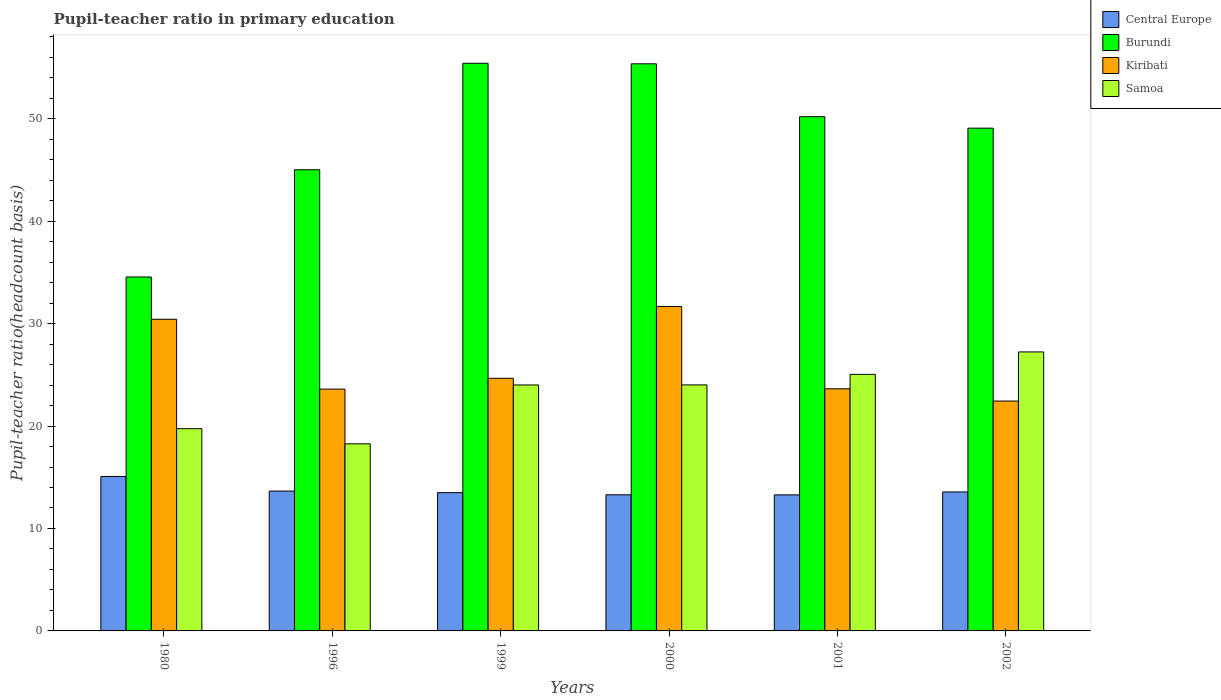How many groups of bars are there?
Provide a short and direct response. 6. How many bars are there on the 5th tick from the left?
Provide a short and direct response. 4. How many bars are there on the 1st tick from the right?
Your answer should be compact. 4. What is the pupil-teacher ratio in primary education in Samoa in 1980?
Keep it short and to the point. 19.74. Across all years, what is the maximum pupil-teacher ratio in primary education in Samoa?
Provide a short and direct response. 27.23. Across all years, what is the minimum pupil-teacher ratio in primary education in Samoa?
Provide a short and direct response. 18.26. In which year was the pupil-teacher ratio in primary education in Kiribati maximum?
Provide a short and direct response. 2000. In which year was the pupil-teacher ratio in primary education in Central Europe minimum?
Ensure brevity in your answer.  2001. What is the total pupil-teacher ratio in primary education in Samoa in the graph?
Make the answer very short. 138.31. What is the difference between the pupil-teacher ratio in primary education in Kiribati in 1996 and that in 2001?
Keep it short and to the point. -0.03. What is the difference between the pupil-teacher ratio in primary education in Central Europe in 1999 and the pupil-teacher ratio in primary education in Samoa in 1996?
Offer a very short reply. -4.77. What is the average pupil-teacher ratio in primary education in Burundi per year?
Your response must be concise. 48.27. In the year 2002, what is the difference between the pupil-teacher ratio in primary education in Burundi and pupil-teacher ratio in primary education in Samoa?
Your answer should be compact. 21.84. In how many years, is the pupil-teacher ratio in primary education in Central Europe greater than 40?
Your answer should be compact. 0. What is the ratio of the pupil-teacher ratio in primary education in Kiribati in 1999 to that in 2001?
Your response must be concise. 1.04. Is the difference between the pupil-teacher ratio in primary education in Burundi in 1999 and 2002 greater than the difference between the pupil-teacher ratio in primary education in Samoa in 1999 and 2002?
Provide a succinct answer. Yes. What is the difference between the highest and the second highest pupil-teacher ratio in primary education in Samoa?
Your response must be concise. 2.19. What is the difference between the highest and the lowest pupil-teacher ratio in primary education in Central Europe?
Keep it short and to the point. 1.79. In how many years, is the pupil-teacher ratio in primary education in Kiribati greater than the average pupil-teacher ratio in primary education in Kiribati taken over all years?
Provide a short and direct response. 2. Is it the case that in every year, the sum of the pupil-teacher ratio in primary education in Samoa and pupil-teacher ratio in primary education in Burundi is greater than the sum of pupil-teacher ratio in primary education in Kiribati and pupil-teacher ratio in primary education in Central Europe?
Your answer should be compact. Yes. What does the 1st bar from the left in 2000 represents?
Provide a short and direct response. Central Europe. What does the 1st bar from the right in 2002 represents?
Make the answer very short. Samoa. Is it the case that in every year, the sum of the pupil-teacher ratio in primary education in Burundi and pupil-teacher ratio in primary education in Samoa is greater than the pupil-teacher ratio in primary education in Kiribati?
Offer a very short reply. Yes. Are all the bars in the graph horizontal?
Offer a very short reply. No. Where does the legend appear in the graph?
Offer a terse response. Top right. What is the title of the graph?
Offer a terse response. Pupil-teacher ratio in primary education. What is the label or title of the Y-axis?
Provide a short and direct response. Pupil-teacher ratio(headcount basis). What is the Pupil-teacher ratio(headcount basis) in Central Europe in 1980?
Make the answer very short. 15.07. What is the Pupil-teacher ratio(headcount basis) in Burundi in 1980?
Ensure brevity in your answer.  34.55. What is the Pupil-teacher ratio(headcount basis) of Kiribati in 1980?
Ensure brevity in your answer.  30.43. What is the Pupil-teacher ratio(headcount basis) in Samoa in 1980?
Ensure brevity in your answer.  19.74. What is the Pupil-teacher ratio(headcount basis) in Central Europe in 1996?
Your response must be concise. 13.65. What is the Pupil-teacher ratio(headcount basis) in Burundi in 1996?
Ensure brevity in your answer.  45.02. What is the Pupil-teacher ratio(headcount basis) of Kiribati in 1996?
Your answer should be compact. 23.61. What is the Pupil-teacher ratio(headcount basis) in Samoa in 1996?
Offer a very short reply. 18.26. What is the Pupil-teacher ratio(headcount basis) in Central Europe in 1999?
Make the answer very short. 13.5. What is the Pupil-teacher ratio(headcount basis) of Burundi in 1999?
Make the answer very short. 55.41. What is the Pupil-teacher ratio(headcount basis) of Kiribati in 1999?
Your answer should be very brief. 24.66. What is the Pupil-teacher ratio(headcount basis) of Samoa in 1999?
Give a very brief answer. 24.01. What is the Pupil-teacher ratio(headcount basis) in Central Europe in 2000?
Offer a terse response. 13.29. What is the Pupil-teacher ratio(headcount basis) of Burundi in 2000?
Keep it short and to the point. 55.36. What is the Pupil-teacher ratio(headcount basis) in Kiribati in 2000?
Provide a succinct answer. 31.67. What is the Pupil-teacher ratio(headcount basis) in Samoa in 2000?
Keep it short and to the point. 24.02. What is the Pupil-teacher ratio(headcount basis) of Central Europe in 2001?
Your response must be concise. 13.28. What is the Pupil-teacher ratio(headcount basis) of Burundi in 2001?
Offer a very short reply. 50.2. What is the Pupil-teacher ratio(headcount basis) of Kiribati in 2001?
Keep it short and to the point. 23.63. What is the Pupil-teacher ratio(headcount basis) of Samoa in 2001?
Your response must be concise. 25.05. What is the Pupil-teacher ratio(headcount basis) in Central Europe in 2002?
Give a very brief answer. 13.57. What is the Pupil-teacher ratio(headcount basis) of Burundi in 2002?
Your response must be concise. 49.08. What is the Pupil-teacher ratio(headcount basis) of Kiribati in 2002?
Ensure brevity in your answer.  22.44. What is the Pupil-teacher ratio(headcount basis) in Samoa in 2002?
Your answer should be very brief. 27.23. Across all years, what is the maximum Pupil-teacher ratio(headcount basis) in Central Europe?
Your response must be concise. 15.07. Across all years, what is the maximum Pupil-teacher ratio(headcount basis) of Burundi?
Offer a very short reply. 55.41. Across all years, what is the maximum Pupil-teacher ratio(headcount basis) in Kiribati?
Offer a terse response. 31.67. Across all years, what is the maximum Pupil-teacher ratio(headcount basis) in Samoa?
Make the answer very short. 27.23. Across all years, what is the minimum Pupil-teacher ratio(headcount basis) of Central Europe?
Provide a succinct answer. 13.28. Across all years, what is the minimum Pupil-teacher ratio(headcount basis) of Burundi?
Give a very brief answer. 34.55. Across all years, what is the minimum Pupil-teacher ratio(headcount basis) in Kiribati?
Offer a very short reply. 22.44. Across all years, what is the minimum Pupil-teacher ratio(headcount basis) of Samoa?
Ensure brevity in your answer.  18.26. What is the total Pupil-teacher ratio(headcount basis) in Central Europe in the graph?
Give a very brief answer. 82.35. What is the total Pupil-teacher ratio(headcount basis) of Burundi in the graph?
Give a very brief answer. 289.61. What is the total Pupil-teacher ratio(headcount basis) of Kiribati in the graph?
Give a very brief answer. 156.43. What is the total Pupil-teacher ratio(headcount basis) of Samoa in the graph?
Ensure brevity in your answer.  138.31. What is the difference between the Pupil-teacher ratio(headcount basis) of Central Europe in 1980 and that in 1996?
Give a very brief answer. 1.42. What is the difference between the Pupil-teacher ratio(headcount basis) in Burundi in 1980 and that in 1996?
Your answer should be compact. -10.47. What is the difference between the Pupil-teacher ratio(headcount basis) of Kiribati in 1980 and that in 1996?
Provide a succinct answer. 6.82. What is the difference between the Pupil-teacher ratio(headcount basis) of Samoa in 1980 and that in 1996?
Ensure brevity in your answer.  1.48. What is the difference between the Pupil-teacher ratio(headcount basis) in Central Europe in 1980 and that in 1999?
Give a very brief answer. 1.58. What is the difference between the Pupil-teacher ratio(headcount basis) in Burundi in 1980 and that in 1999?
Make the answer very short. -20.86. What is the difference between the Pupil-teacher ratio(headcount basis) of Kiribati in 1980 and that in 1999?
Offer a very short reply. 5.76. What is the difference between the Pupil-teacher ratio(headcount basis) of Samoa in 1980 and that in 1999?
Provide a short and direct response. -4.27. What is the difference between the Pupil-teacher ratio(headcount basis) in Central Europe in 1980 and that in 2000?
Provide a short and direct response. 1.78. What is the difference between the Pupil-teacher ratio(headcount basis) of Burundi in 1980 and that in 2000?
Your response must be concise. -20.81. What is the difference between the Pupil-teacher ratio(headcount basis) of Kiribati in 1980 and that in 2000?
Your answer should be very brief. -1.24. What is the difference between the Pupil-teacher ratio(headcount basis) of Samoa in 1980 and that in 2000?
Your answer should be very brief. -4.27. What is the difference between the Pupil-teacher ratio(headcount basis) in Central Europe in 1980 and that in 2001?
Give a very brief answer. 1.79. What is the difference between the Pupil-teacher ratio(headcount basis) in Burundi in 1980 and that in 2001?
Give a very brief answer. -15.65. What is the difference between the Pupil-teacher ratio(headcount basis) of Kiribati in 1980 and that in 2001?
Make the answer very short. 6.79. What is the difference between the Pupil-teacher ratio(headcount basis) in Samoa in 1980 and that in 2001?
Ensure brevity in your answer.  -5.3. What is the difference between the Pupil-teacher ratio(headcount basis) of Central Europe in 1980 and that in 2002?
Provide a succinct answer. 1.51. What is the difference between the Pupil-teacher ratio(headcount basis) of Burundi in 1980 and that in 2002?
Ensure brevity in your answer.  -14.53. What is the difference between the Pupil-teacher ratio(headcount basis) in Kiribati in 1980 and that in 2002?
Provide a short and direct response. 7.99. What is the difference between the Pupil-teacher ratio(headcount basis) of Samoa in 1980 and that in 2002?
Offer a terse response. -7.49. What is the difference between the Pupil-teacher ratio(headcount basis) in Central Europe in 1996 and that in 1999?
Make the answer very short. 0.16. What is the difference between the Pupil-teacher ratio(headcount basis) of Burundi in 1996 and that in 1999?
Ensure brevity in your answer.  -10.4. What is the difference between the Pupil-teacher ratio(headcount basis) of Kiribati in 1996 and that in 1999?
Your answer should be very brief. -1.06. What is the difference between the Pupil-teacher ratio(headcount basis) of Samoa in 1996 and that in 1999?
Your answer should be very brief. -5.74. What is the difference between the Pupil-teacher ratio(headcount basis) in Central Europe in 1996 and that in 2000?
Offer a very short reply. 0.36. What is the difference between the Pupil-teacher ratio(headcount basis) in Burundi in 1996 and that in 2000?
Ensure brevity in your answer.  -10.34. What is the difference between the Pupil-teacher ratio(headcount basis) of Kiribati in 1996 and that in 2000?
Your answer should be very brief. -8.06. What is the difference between the Pupil-teacher ratio(headcount basis) in Samoa in 1996 and that in 2000?
Your response must be concise. -5.75. What is the difference between the Pupil-teacher ratio(headcount basis) of Central Europe in 1996 and that in 2001?
Make the answer very short. 0.37. What is the difference between the Pupil-teacher ratio(headcount basis) of Burundi in 1996 and that in 2001?
Your response must be concise. -5.18. What is the difference between the Pupil-teacher ratio(headcount basis) in Kiribati in 1996 and that in 2001?
Make the answer very short. -0.03. What is the difference between the Pupil-teacher ratio(headcount basis) of Samoa in 1996 and that in 2001?
Ensure brevity in your answer.  -6.78. What is the difference between the Pupil-teacher ratio(headcount basis) of Central Europe in 1996 and that in 2002?
Provide a short and direct response. 0.09. What is the difference between the Pupil-teacher ratio(headcount basis) of Burundi in 1996 and that in 2002?
Offer a very short reply. -4.06. What is the difference between the Pupil-teacher ratio(headcount basis) of Kiribati in 1996 and that in 2002?
Provide a succinct answer. 1.17. What is the difference between the Pupil-teacher ratio(headcount basis) in Samoa in 1996 and that in 2002?
Keep it short and to the point. -8.97. What is the difference between the Pupil-teacher ratio(headcount basis) in Central Europe in 1999 and that in 2000?
Provide a succinct answer. 0.21. What is the difference between the Pupil-teacher ratio(headcount basis) of Burundi in 1999 and that in 2000?
Your answer should be very brief. 0.05. What is the difference between the Pupil-teacher ratio(headcount basis) in Kiribati in 1999 and that in 2000?
Your response must be concise. -7. What is the difference between the Pupil-teacher ratio(headcount basis) in Samoa in 1999 and that in 2000?
Offer a terse response. -0.01. What is the difference between the Pupil-teacher ratio(headcount basis) in Central Europe in 1999 and that in 2001?
Offer a very short reply. 0.21. What is the difference between the Pupil-teacher ratio(headcount basis) of Burundi in 1999 and that in 2001?
Provide a short and direct response. 5.22. What is the difference between the Pupil-teacher ratio(headcount basis) of Kiribati in 1999 and that in 2001?
Ensure brevity in your answer.  1.03. What is the difference between the Pupil-teacher ratio(headcount basis) in Samoa in 1999 and that in 2001?
Provide a short and direct response. -1.04. What is the difference between the Pupil-teacher ratio(headcount basis) in Central Europe in 1999 and that in 2002?
Your answer should be very brief. -0.07. What is the difference between the Pupil-teacher ratio(headcount basis) in Burundi in 1999 and that in 2002?
Your response must be concise. 6.34. What is the difference between the Pupil-teacher ratio(headcount basis) of Kiribati in 1999 and that in 2002?
Offer a very short reply. 2.22. What is the difference between the Pupil-teacher ratio(headcount basis) in Samoa in 1999 and that in 2002?
Offer a terse response. -3.23. What is the difference between the Pupil-teacher ratio(headcount basis) of Central Europe in 2000 and that in 2001?
Keep it short and to the point. 0.01. What is the difference between the Pupil-teacher ratio(headcount basis) in Burundi in 2000 and that in 2001?
Provide a succinct answer. 5.16. What is the difference between the Pupil-teacher ratio(headcount basis) in Kiribati in 2000 and that in 2001?
Give a very brief answer. 8.03. What is the difference between the Pupil-teacher ratio(headcount basis) of Samoa in 2000 and that in 2001?
Give a very brief answer. -1.03. What is the difference between the Pupil-teacher ratio(headcount basis) in Central Europe in 2000 and that in 2002?
Offer a very short reply. -0.28. What is the difference between the Pupil-teacher ratio(headcount basis) in Burundi in 2000 and that in 2002?
Keep it short and to the point. 6.28. What is the difference between the Pupil-teacher ratio(headcount basis) in Kiribati in 2000 and that in 2002?
Your answer should be compact. 9.23. What is the difference between the Pupil-teacher ratio(headcount basis) of Samoa in 2000 and that in 2002?
Provide a short and direct response. -3.22. What is the difference between the Pupil-teacher ratio(headcount basis) in Central Europe in 2001 and that in 2002?
Your response must be concise. -0.28. What is the difference between the Pupil-teacher ratio(headcount basis) of Burundi in 2001 and that in 2002?
Offer a very short reply. 1.12. What is the difference between the Pupil-teacher ratio(headcount basis) of Kiribati in 2001 and that in 2002?
Make the answer very short. 1.2. What is the difference between the Pupil-teacher ratio(headcount basis) in Samoa in 2001 and that in 2002?
Make the answer very short. -2.19. What is the difference between the Pupil-teacher ratio(headcount basis) in Central Europe in 1980 and the Pupil-teacher ratio(headcount basis) in Burundi in 1996?
Your answer should be very brief. -29.95. What is the difference between the Pupil-teacher ratio(headcount basis) of Central Europe in 1980 and the Pupil-teacher ratio(headcount basis) of Kiribati in 1996?
Your answer should be very brief. -8.53. What is the difference between the Pupil-teacher ratio(headcount basis) of Central Europe in 1980 and the Pupil-teacher ratio(headcount basis) of Samoa in 1996?
Provide a short and direct response. -3.19. What is the difference between the Pupil-teacher ratio(headcount basis) in Burundi in 1980 and the Pupil-teacher ratio(headcount basis) in Kiribati in 1996?
Your response must be concise. 10.95. What is the difference between the Pupil-teacher ratio(headcount basis) in Burundi in 1980 and the Pupil-teacher ratio(headcount basis) in Samoa in 1996?
Keep it short and to the point. 16.29. What is the difference between the Pupil-teacher ratio(headcount basis) of Kiribati in 1980 and the Pupil-teacher ratio(headcount basis) of Samoa in 1996?
Provide a succinct answer. 12.16. What is the difference between the Pupil-teacher ratio(headcount basis) of Central Europe in 1980 and the Pupil-teacher ratio(headcount basis) of Burundi in 1999?
Ensure brevity in your answer.  -40.34. What is the difference between the Pupil-teacher ratio(headcount basis) of Central Europe in 1980 and the Pupil-teacher ratio(headcount basis) of Kiribati in 1999?
Make the answer very short. -9.59. What is the difference between the Pupil-teacher ratio(headcount basis) in Central Europe in 1980 and the Pupil-teacher ratio(headcount basis) in Samoa in 1999?
Provide a succinct answer. -8.94. What is the difference between the Pupil-teacher ratio(headcount basis) of Burundi in 1980 and the Pupil-teacher ratio(headcount basis) of Kiribati in 1999?
Give a very brief answer. 9.89. What is the difference between the Pupil-teacher ratio(headcount basis) of Burundi in 1980 and the Pupil-teacher ratio(headcount basis) of Samoa in 1999?
Provide a succinct answer. 10.54. What is the difference between the Pupil-teacher ratio(headcount basis) of Kiribati in 1980 and the Pupil-teacher ratio(headcount basis) of Samoa in 1999?
Offer a terse response. 6.42. What is the difference between the Pupil-teacher ratio(headcount basis) of Central Europe in 1980 and the Pupil-teacher ratio(headcount basis) of Burundi in 2000?
Offer a terse response. -40.29. What is the difference between the Pupil-teacher ratio(headcount basis) in Central Europe in 1980 and the Pupil-teacher ratio(headcount basis) in Kiribati in 2000?
Your answer should be very brief. -16.59. What is the difference between the Pupil-teacher ratio(headcount basis) in Central Europe in 1980 and the Pupil-teacher ratio(headcount basis) in Samoa in 2000?
Your answer should be very brief. -8.94. What is the difference between the Pupil-teacher ratio(headcount basis) in Burundi in 1980 and the Pupil-teacher ratio(headcount basis) in Kiribati in 2000?
Provide a short and direct response. 2.89. What is the difference between the Pupil-teacher ratio(headcount basis) of Burundi in 1980 and the Pupil-teacher ratio(headcount basis) of Samoa in 2000?
Provide a short and direct response. 10.54. What is the difference between the Pupil-teacher ratio(headcount basis) in Kiribati in 1980 and the Pupil-teacher ratio(headcount basis) in Samoa in 2000?
Provide a succinct answer. 6.41. What is the difference between the Pupil-teacher ratio(headcount basis) of Central Europe in 1980 and the Pupil-teacher ratio(headcount basis) of Burundi in 2001?
Your answer should be compact. -35.13. What is the difference between the Pupil-teacher ratio(headcount basis) of Central Europe in 1980 and the Pupil-teacher ratio(headcount basis) of Kiribati in 2001?
Your answer should be very brief. -8.56. What is the difference between the Pupil-teacher ratio(headcount basis) of Central Europe in 1980 and the Pupil-teacher ratio(headcount basis) of Samoa in 2001?
Keep it short and to the point. -9.97. What is the difference between the Pupil-teacher ratio(headcount basis) of Burundi in 1980 and the Pupil-teacher ratio(headcount basis) of Kiribati in 2001?
Your response must be concise. 10.92. What is the difference between the Pupil-teacher ratio(headcount basis) of Burundi in 1980 and the Pupil-teacher ratio(headcount basis) of Samoa in 2001?
Ensure brevity in your answer.  9.51. What is the difference between the Pupil-teacher ratio(headcount basis) of Kiribati in 1980 and the Pupil-teacher ratio(headcount basis) of Samoa in 2001?
Keep it short and to the point. 5.38. What is the difference between the Pupil-teacher ratio(headcount basis) of Central Europe in 1980 and the Pupil-teacher ratio(headcount basis) of Burundi in 2002?
Provide a short and direct response. -34. What is the difference between the Pupil-teacher ratio(headcount basis) of Central Europe in 1980 and the Pupil-teacher ratio(headcount basis) of Kiribati in 2002?
Give a very brief answer. -7.37. What is the difference between the Pupil-teacher ratio(headcount basis) in Central Europe in 1980 and the Pupil-teacher ratio(headcount basis) in Samoa in 2002?
Your response must be concise. -12.16. What is the difference between the Pupil-teacher ratio(headcount basis) in Burundi in 1980 and the Pupil-teacher ratio(headcount basis) in Kiribati in 2002?
Provide a succinct answer. 12.11. What is the difference between the Pupil-teacher ratio(headcount basis) in Burundi in 1980 and the Pupil-teacher ratio(headcount basis) in Samoa in 2002?
Your answer should be compact. 7.32. What is the difference between the Pupil-teacher ratio(headcount basis) in Kiribati in 1980 and the Pupil-teacher ratio(headcount basis) in Samoa in 2002?
Give a very brief answer. 3.19. What is the difference between the Pupil-teacher ratio(headcount basis) in Central Europe in 1996 and the Pupil-teacher ratio(headcount basis) in Burundi in 1999?
Offer a very short reply. -41.76. What is the difference between the Pupil-teacher ratio(headcount basis) of Central Europe in 1996 and the Pupil-teacher ratio(headcount basis) of Kiribati in 1999?
Provide a succinct answer. -11.01. What is the difference between the Pupil-teacher ratio(headcount basis) of Central Europe in 1996 and the Pupil-teacher ratio(headcount basis) of Samoa in 1999?
Your answer should be very brief. -10.36. What is the difference between the Pupil-teacher ratio(headcount basis) in Burundi in 1996 and the Pupil-teacher ratio(headcount basis) in Kiribati in 1999?
Make the answer very short. 20.36. What is the difference between the Pupil-teacher ratio(headcount basis) of Burundi in 1996 and the Pupil-teacher ratio(headcount basis) of Samoa in 1999?
Ensure brevity in your answer.  21.01. What is the difference between the Pupil-teacher ratio(headcount basis) in Kiribati in 1996 and the Pupil-teacher ratio(headcount basis) in Samoa in 1999?
Provide a short and direct response. -0.4. What is the difference between the Pupil-teacher ratio(headcount basis) in Central Europe in 1996 and the Pupil-teacher ratio(headcount basis) in Burundi in 2000?
Your answer should be compact. -41.71. What is the difference between the Pupil-teacher ratio(headcount basis) in Central Europe in 1996 and the Pupil-teacher ratio(headcount basis) in Kiribati in 2000?
Ensure brevity in your answer.  -18.01. What is the difference between the Pupil-teacher ratio(headcount basis) of Central Europe in 1996 and the Pupil-teacher ratio(headcount basis) of Samoa in 2000?
Give a very brief answer. -10.36. What is the difference between the Pupil-teacher ratio(headcount basis) of Burundi in 1996 and the Pupil-teacher ratio(headcount basis) of Kiribati in 2000?
Your answer should be very brief. 13.35. What is the difference between the Pupil-teacher ratio(headcount basis) in Burundi in 1996 and the Pupil-teacher ratio(headcount basis) in Samoa in 2000?
Your answer should be very brief. 21. What is the difference between the Pupil-teacher ratio(headcount basis) in Kiribati in 1996 and the Pupil-teacher ratio(headcount basis) in Samoa in 2000?
Provide a succinct answer. -0.41. What is the difference between the Pupil-teacher ratio(headcount basis) in Central Europe in 1996 and the Pupil-teacher ratio(headcount basis) in Burundi in 2001?
Your answer should be compact. -36.55. What is the difference between the Pupil-teacher ratio(headcount basis) in Central Europe in 1996 and the Pupil-teacher ratio(headcount basis) in Kiribati in 2001?
Make the answer very short. -9.98. What is the difference between the Pupil-teacher ratio(headcount basis) of Central Europe in 1996 and the Pupil-teacher ratio(headcount basis) of Samoa in 2001?
Your answer should be compact. -11.39. What is the difference between the Pupil-teacher ratio(headcount basis) in Burundi in 1996 and the Pupil-teacher ratio(headcount basis) in Kiribati in 2001?
Keep it short and to the point. 21.38. What is the difference between the Pupil-teacher ratio(headcount basis) in Burundi in 1996 and the Pupil-teacher ratio(headcount basis) in Samoa in 2001?
Give a very brief answer. 19.97. What is the difference between the Pupil-teacher ratio(headcount basis) of Kiribati in 1996 and the Pupil-teacher ratio(headcount basis) of Samoa in 2001?
Your answer should be very brief. -1.44. What is the difference between the Pupil-teacher ratio(headcount basis) of Central Europe in 1996 and the Pupil-teacher ratio(headcount basis) of Burundi in 2002?
Keep it short and to the point. -35.43. What is the difference between the Pupil-teacher ratio(headcount basis) in Central Europe in 1996 and the Pupil-teacher ratio(headcount basis) in Kiribati in 2002?
Your answer should be compact. -8.79. What is the difference between the Pupil-teacher ratio(headcount basis) of Central Europe in 1996 and the Pupil-teacher ratio(headcount basis) of Samoa in 2002?
Provide a succinct answer. -13.58. What is the difference between the Pupil-teacher ratio(headcount basis) of Burundi in 1996 and the Pupil-teacher ratio(headcount basis) of Kiribati in 2002?
Your answer should be very brief. 22.58. What is the difference between the Pupil-teacher ratio(headcount basis) in Burundi in 1996 and the Pupil-teacher ratio(headcount basis) in Samoa in 2002?
Provide a short and direct response. 17.78. What is the difference between the Pupil-teacher ratio(headcount basis) in Kiribati in 1996 and the Pupil-teacher ratio(headcount basis) in Samoa in 2002?
Offer a terse response. -3.63. What is the difference between the Pupil-teacher ratio(headcount basis) in Central Europe in 1999 and the Pupil-teacher ratio(headcount basis) in Burundi in 2000?
Your answer should be compact. -41.86. What is the difference between the Pupil-teacher ratio(headcount basis) of Central Europe in 1999 and the Pupil-teacher ratio(headcount basis) of Kiribati in 2000?
Provide a short and direct response. -18.17. What is the difference between the Pupil-teacher ratio(headcount basis) of Central Europe in 1999 and the Pupil-teacher ratio(headcount basis) of Samoa in 2000?
Your response must be concise. -10.52. What is the difference between the Pupil-teacher ratio(headcount basis) in Burundi in 1999 and the Pupil-teacher ratio(headcount basis) in Kiribati in 2000?
Keep it short and to the point. 23.75. What is the difference between the Pupil-teacher ratio(headcount basis) in Burundi in 1999 and the Pupil-teacher ratio(headcount basis) in Samoa in 2000?
Provide a succinct answer. 31.4. What is the difference between the Pupil-teacher ratio(headcount basis) in Kiribati in 1999 and the Pupil-teacher ratio(headcount basis) in Samoa in 2000?
Give a very brief answer. 0.65. What is the difference between the Pupil-teacher ratio(headcount basis) of Central Europe in 1999 and the Pupil-teacher ratio(headcount basis) of Burundi in 2001?
Offer a terse response. -36.7. What is the difference between the Pupil-teacher ratio(headcount basis) in Central Europe in 1999 and the Pupil-teacher ratio(headcount basis) in Kiribati in 2001?
Provide a short and direct response. -10.14. What is the difference between the Pupil-teacher ratio(headcount basis) of Central Europe in 1999 and the Pupil-teacher ratio(headcount basis) of Samoa in 2001?
Provide a short and direct response. -11.55. What is the difference between the Pupil-teacher ratio(headcount basis) of Burundi in 1999 and the Pupil-teacher ratio(headcount basis) of Kiribati in 2001?
Provide a short and direct response. 31.78. What is the difference between the Pupil-teacher ratio(headcount basis) of Burundi in 1999 and the Pupil-teacher ratio(headcount basis) of Samoa in 2001?
Provide a succinct answer. 30.37. What is the difference between the Pupil-teacher ratio(headcount basis) in Kiribati in 1999 and the Pupil-teacher ratio(headcount basis) in Samoa in 2001?
Make the answer very short. -0.38. What is the difference between the Pupil-teacher ratio(headcount basis) in Central Europe in 1999 and the Pupil-teacher ratio(headcount basis) in Burundi in 2002?
Offer a terse response. -35.58. What is the difference between the Pupil-teacher ratio(headcount basis) in Central Europe in 1999 and the Pupil-teacher ratio(headcount basis) in Kiribati in 2002?
Provide a short and direct response. -8.94. What is the difference between the Pupil-teacher ratio(headcount basis) in Central Europe in 1999 and the Pupil-teacher ratio(headcount basis) in Samoa in 2002?
Your answer should be very brief. -13.74. What is the difference between the Pupil-teacher ratio(headcount basis) in Burundi in 1999 and the Pupil-teacher ratio(headcount basis) in Kiribati in 2002?
Make the answer very short. 32.97. What is the difference between the Pupil-teacher ratio(headcount basis) in Burundi in 1999 and the Pupil-teacher ratio(headcount basis) in Samoa in 2002?
Your answer should be compact. 28.18. What is the difference between the Pupil-teacher ratio(headcount basis) in Kiribati in 1999 and the Pupil-teacher ratio(headcount basis) in Samoa in 2002?
Make the answer very short. -2.57. What is the difference between the Pupil-teacher ratio(headcount basis) of Central Europe in 2000 and the Pupil-teacher ratio(headcount basis) of Burundi in 2001?
Make the answer very short. -36.91. What is the difference between the Pupil-teacher ratio(headcount basis) of Central Europe in 2000 and the Pupil-teacher ratio(headcount basis) of Kiribati in 2001?
Provide a short and direct response. -10.35. What is the difference between the Pupil-teacher ratio(headcount basis) of Central Europe in 2000 and the Pupil-teacher ratio(headcount basis) of Samoa in 2001?
Your response must be concise. -11.76. What is the difference between the Pupil-teacher ratio(headcount basis) of Burundi in 2000 and the Pupil-teacher ratio(headcount basis) of Kiribati in 2001?
Give a very brief answer. 31.73. What is the difference between the Pupil-teacher ratio(headcount basis) in Burundi in 2000 and the Pupil-teacher ratio(headcount basis) in Samoa in 2001?
Provide a short and direct response. 30.31. What is the difference between the Pupil-teacher ratio(headcount basis) of Kiribati in 2000 and the Pupil-teacher ratio(headcount basis) of Samoa in 2001?
Your answer should be very brief. 6.62. What is the difference between the Pupil-teacher ratio(headcount basis) in Central Europe in 2000 and the Pupil-teacher ratio(headcount basis) in Burundi in 2002?
Ensure brevity in your answer.  -35.79. What is the difference between the Pupil-teacher ratio(headcount basis) of Central Europe in 2000 and the Pupil-teacher ratio(headcount basis) of Kiribati in 2002?
Offer a terse response. -9.15. What is the difference between the Pupil-teacher ratio(headcount basis) in Central Europe in 2000 and the Pupil-teacher ratio(headcount basis) in Samoa in 2002?
Keep it short and to the point. -13.95. What is the difference between the Pupil-teacher ratio(headcount basis) in Burundi in 2000 and the Pupil-teacher ratio(headcount basis) in Kiribati in 2002?
Give a very brief answer. 32.92. What is the difference between the Pupil-teacher ratio(headcount basis) of Burundi in 2000 and the Pupil-teacher ratio(headcount basis) of Samoa in 2002?
Ensure brevity in your answer.  28.13. What is the difference between the Pupil-teacher ratio(headcount basis) in Kiribati in 2000 and the Pupil-teacher ratio(headcount basis) in Samoa in 2002?
Your response must be concise. 4.43. What is the difference between the Pupil-teacher ratio(headcount basis) in Central Europe in 2001 and the Pupil-teacher ratio(headcount basis) in Burundi in 2002?
Offer a very short reply. -35.79. What is the difference between the Pupil-teacher ratio(headcount basis) of Central Europe in 2001 and the Pupil-teacher ratio(headcount basis) of Kiribati in 2002?
Offer a very short reply. -9.16. What is the difference between the Pupil-teacher ratio(headcount basis) in Central Europe in 2001 and the Pupil-teacher ratio(headcount basis) in Samoa in 2002?
Provide a short and direct response. -13.95. What is the difference between the Pupil-teacher ratio(headcount basis) of Burundi in 2001 and the Pupil-teacher ratio(headcount basis) of Kiribati in 2002?
Make the answer very short. 27.76. What is the difference between the Pupil-teacher ratio(headcount basis) in Burundi in 2001 and the Pupil-teacher ratio(headcount basis) in Samoa in 2002?
Provide a short and direct response. 22.96. What is the difference between the Pupil-teacher ratio(headcount basis) of Kiribati in 2001 and the Pupil-teacher ratio(headcount basis) of Samoa in 2002?
Offer a very short reply. -3.6. What is the average Pupil-teacher ratio(headcount basis) in Central Europe per year?
Your answer should be very brief. 13.73. What is the average Pupil-teacher ratio(headcount basis) of Burundi per year?
Your response must be concise. 48.27. What is the average Pupil-teacher ratio(headcount basis) in Kiribati per year?
Keep it short and to the point. 26.07. What is the average Pupil-teacher ratio(headcount basis) in Samoa per year?
Your answer should be compact. 23.05. In the year 1980, what is the difference between the Pupil-teacher ratio(headcount basis) of Central Europe and Pupil-teacher ratio(headcount basis) of Burundi?
Your response must be concise. -19.48. In the year 1980, what is the difference between the Pupil-teacher ratio(headcount basis) of Central Europe and Pupil-teacher ratio(headcount basis) of Kiribati?
Offer a very short reply. -15.35. In the year 1980, what is the difference between the Pupil-teacher ratio(headcount basis) in Central Europe and Pupil-teacher ratio(headcount basis) in Samoa?
Provide a succinct answer. -4.67. In the year 1980, what is the difference between the Pupil-teacher ratio(headcount basis) in Burundi and Pupil-teacher ratio(headcount basis) in Kiribati?
Keep it short and to the point. 4.13. In the year 1980, what is the difference between the Pupil-teacher ratio(headcount basis) in Burundi and Pupil-teacher ratio(headcount basis) in Samoa?
Give a very brief answer. 14.81. In the year 1980, what is the difference between the Pupil-teacher ratio(headcount basis) in Kiribati and Pupil-teacher ratio(headcount basis) in Samoa?
Your answer should be compact. 10.68. In the year 1996, what is the difference between the Pupil-teacher ratio(headcount basis) in Central Europe and Pupil-teacher ratio(headcount basis) in Burundi?
Keep it short and to the point. -31.37. In the year 1996, what is the difference between the Pupil-teacher ratio(headcount basis) of Central Europe and Pupil-teacher ratio(headcount basis) of Kiribati?
Offer a very short reply. -9.95. In the year 1996, what is the difference between the Pupil-teacher ratio(headcount basis) of Central Europe and Pupil-teacher ratio(headcount basis) of Samoa?
Your response must be concise. -4.61. In the year 1996, what is the difference between the Pupil-teacher ratio(headcount basis) of Burundi and Pupil-teacher ratio(headcount basis) of Kiribati?
Keep it short and to the point. 21.41. In the year 1996, what is the difference between the Pupil-teacher ratio(headcount basis) in Burundi and Pupil-teacher ratio(headcount basis) in Samoa?
Keep it short and to the point. 26.75. In the year 1996, what is the difference between the Pupil-teacher ratio(headcount basis) of Kiribati and Pupil-teacher ratio(headcount basis) of Samoa?
Provide a short and direct response. 5.34. In the year 1999, what is the difference between the Pupil-teacher ratio(headcount basis) of Central Europe and Pupil-teacher ratio(headcount basis) of Burundi?
Keep it short and to the point. -41.92. In the year 1999, what is the difference between the Pupil-teacher ratio(headcount basis) of Central Europe and Pupil-teacher ratio(headcount basis) of Kiribati?
Your answer should be compact. -11.17. In the year 1999, what is the difference between the Pupil-teacher ratio(headcount basis) in Central Europe and Pupil-teacher ratio(headcount basis) in Samoa?
Provide a short and direct response. -10.51. In the year 1999, what is the difference between the Pupil-teacher ratio(headcount basis) of Burundi and Pupil-teacher ratio(headcount basis) of Kiribati?
Give a very brief answer. 30.75. In the year 1999, what is the difference between the Pupil-teacher ratio(headcount basis) in Burundi and Pupil-teacher ratio(headcount basis) in Samoa?
Provide a succinct answer. 31.4. In the year 1999, what is the difference between the Pupil-teacher ratio(headcount basis) of Kiribati and Pupil-teacher ratio(headcount basis) of Samoa?
Keep it short and to the point. 0.65. In the year 2000, what is the difference between the Pupil-teacher ratio(headcount basis) of Central Europe and Pupil-teacher ratio(headcount basis) of Burundi?
Provide a succinct answer. -42.07. In the year 2000, what is the difference between the Pupil-teacher ratio(headcount basis) of Central Europe and Pupil-teacher ratio(headcount basis) of Kiribati?
Keep it short and to the point. -18.38. In the year 2000, what is the difference between the Pupil-teacher ratio(headcount basis) in Central Europe and Pupil-teacher ratio(headcount basis) in Samoa?
Keep it short and to the point. -10.73. In the year 2000, what is the difference between the Pupil-teacher ratio(headcount basis) of Burundi and Pupil-teacher ratio(headcount basis) of Kiribati?
Your answer should be compact. 23.69. In the year 2000, what is the difference between the Pupil-teacher ratio(headcount basis) of Burundi and Pupil-teacher ratio(headcount basis) of Samoa?
Make the answer very short. 31.34. In the year 2000, what is the difference between the Pupil-teacher ratio(headcount basis) of Kiribati and Pupil-teacher ratio(headcount basis) of Samoa?
Your answer should be compact. 7.65. In the year 2001, what is the difference between the Pupil-teacher ratio(headcount basis) in Central Europe and Pupil-teacher ratio(headcount basis) in Burundi?
Your response must be concise. -36.92. In the year 2001, what is the difference between the Pupil-teacher ratio(headcount basis) in Central Europe and Pupil-teacher ratio(headcount basis) in Kiribati?
Keep it short and to the point. -10.35. In the year 2001, what is the difference between the Pupil-teacher ratio(headcount basis) of Central Europe and Pupil-teacher ratio(headcount basis) of Samoa?
Offer a very short reply. -11.76. In the year 2001, what is the difference between the Pupil-teacher ratio(headcount basis) of Burundi and Pupil-teacher ratio(headcount basis) of Kiribati?
Give a very brief answer. 26.56. In the year 2001, what is the difference between the Pupil-teacher ratio(headcount basis) of Burundi and Pupil-teacher ratio(headcount basis) of Samoa?
Make the answer very short. 25.15. In the year 2001, what is the difference between the Pupil-teacher ratio(headcount basis) of Kiribati and Pupil-teacher ratio(headcount basis) of Samoa?
Offer a very short reply. -1.41. In the year 2002, what is the difference between the Pupil-teacher ratio(headcount basis) in Central Europe and Pupil-teacher ratio(headcount basis) in Burundi?
Ensure brevity in your answer.  -35.51. In the year 2002, what is the difference between the Pupil-teacher ratio(headcount basis) of Central Europe and Pupil-teacher ratio(headcount basis) of Kiribati?
Offer a very short reply. -8.87. In the year 2002, what is the difference between the Pupil-teacher ratio(headcount basis) in Central Europe and Pupil-teacher ratio(headcount basis) in Samoa?
Keep it short and to the point. -13.67. In the year 2002, what is the difference between the Pupil-teacher ratio(headcount basis) in Burundi and Pupil-teacher ratio(headcount basis) in Kiribati?
Your answer should be very brief. 26.64. In the year 2002, what is the difference between the Pupil-teacher ratio(headcount basis) of Burundi and Pupil-teacher ratio(headcount basis) of Samoa?
Offer a terse response. 21.84. In the year 2002, what is the difference between the Pupil-teacher ratio(headcount basis) in Kiribati and Pupil-teacher ratio(headcount basis) in Samoa?
Provide a short and direct response. -4.8. What is the ratio of the Pupil-teacher ratio(headcount basis) in Central Europe in 1980 to that in 1996?
Your answer should be compact. 1.1. What is the ratio of the Pupil-teacher ratio(headcount basis) of Burundi in 1980 to that in 1996?
Provide a succinct answer. 0.77. What is the ratio of the Pupil-teacher ratio(headcount basis) of Kiribati in 1980 to that in 1996?
Your answer should be very brief. 1.29. What is the ratio of the Pupil-teacher ratio(headcount basis) in Samoa in 1980 to that in 1996?
Your response must be concise. 1.08. What is the ratio of the Pupil-teacher ratio(headcount basis) of Central Europe in 1980 to that in 1999?
Ensure brevity in your answer.  1.12. What is the ratio of the Pupil-teacher ratio(headcount basis) of Burundi in 1980 to that in 1999?
Provide a succinct answer. 0.62. What is the ratio of the Pupil-teacher ratio(headcount basis) of Kiribati in 1980 to that in 1999?
Your answer should be very brief. 1.23. What is the ratio of the Pupil-teacher ratio(headcount basis) in Samoa in 1980 to that in 1999?
Keep it short and to the point. 0.82. What is the ratio of the Pupil-teacher ratio(headcount basis) in Central Europe in 1980 to that in 2000?
Make the answer very short. 1.13. What is the ratio of the Pupil-teacher ratio(headcount basis) of Burundi in 1980 to that in 2000?
Provide a succinct answer. 0.62. What is the ratio of the Pupil-teacher ratio(headcount basis) of Kiribati in 1980 to that in 2000?
Your response must be concise. 0.96. What is the ratio of the Pupil-teacher ratio(headcount basis) in Samoa in 1980 to that in 2000?
Your response must be concise. 0.82. What is the ratio of the Pupil-teacher ratio(headcount basis) in Central Europe in 1980 to that in 2001?
Offer a terse response. 1.13. What is the ratio of the Pupil-teacher ratio(headcount basis) of Burundi in 1980 to that in 2001?
Provide a short and direct response. 0.69. What is the ratio of the Pupil-teacher ratio(headcount basis) of Kiribati in 1980 to that in 2001?
Provide a succinct answer. 1.29. What is the ratio of the Pupil-teacher ratio(headcount basis) of Samoa in 1980 to that in 2001?
Offer a very short reply. 0.79. What is the ratio of the Pupil-teacher ratio(headcount basis) in Central Europe in 1980 to that in 2002?
Make the answer very short. 1.11. What is the ratio of the Pupil-teacher ratio(headcount basis) in Burundi in 1980 to that in 2002?
Offer a very short reply. 0.7. What is the ratio of the Pupil-teacher ratio(headcount basis) in Kiribati in 1980 to that in 2002?
Offer a very short reply. 1.36. What is the ratio of the Pupil-teacher ratio(headcount basis) in Samoa in 1980 to that in 2002?
Offer a terse response. 0.72. What is the ratio of the Pupil-teacher ratio(headcount basis) of Central Europe in 1996 to that in 1999?
Provide a short and direct response. 1.01. What is the ratio of the Pupil-teacher ratio(headcount basis) of Burundi in 1996 to that in 1999?
Keep it short and to the point. 0.81. What is the ratio of the Pupil-teacher ratio(headcount basis) in Kiribati in 1996 to that in 1999?
Keep it short and to the point. 0.96. What is the ratio of the Pupil-teacher ratio(headcount basis) of Samoa in 1996 to that in 1999?
Your answer should be very brief. 0.76. What is the ratio of the Pupil-teacher ratio(headcount basis) in Central Europe in 1996 to that in 2000?
Provide a succinct answer. 1.03. What is the ratio of the Pupil-teacher ratio(headcount basis) in Burundi in 1996 to that in 2000?
Provide a succinct answer. 0.81. What is the ratio of the Pupil-teacher ratio(headcount basis) in Kiribati in 1996 to that in 2000?
Your answer should be very brief. 0.75. What is the ratio of the Pupil-teacher ratio(headcount basis) of Samoa in 1996 to that in 2000?
Offer a very short reply. 0.76. What is the ratio of the Pupil-teacher ratio(headcount basis) of Central Europe in 1996 to that in 2001?
Your answer should be very brief. 1.03. What is the ratio of the Pupil-teacher ratio(headcount basis) in Burundi in 1996 to that in 2001?
Ensure brevity in your answer.  0.9. What is the ratio of the Pupil-teacher ratio(headcount basis) in Kiribati in 1996 to that in 2001?
Provide a short and direct response. 1. What is the ratio of the Pupil-teacher ratio(headcount basis) in Samoa in 1996 to that in 2001?
Your response must be concise. 0.73. What is the ratio of the Pupil-teacher ratio(headcount basis) in Central Europe in 1996 to that in 2002?
Your answer should be compact. 1.01. What is the ratio of the Pupil-teacher ratio(headcount basis) in Burundi in 1996 to that in 2002?
Offer a very short reply. 0.92. What is the ratio of the Pupil-teacher ratio(headcount basis) of Kiribati in 1996 to that in 2002?
Your answer should be very brief. 1.05. What is the ratio of the Pupil-teacher ratio(headcount basis) in Samoa in 1996 to that in 2002?
Provide a succinct answer. 0.67. What is the ratio of the Pupil-teacher ratio(headcount basis) of Central Europe in 1999 to that in 2000?
Provide a succinct answer. 1.02. What is the ratio of the Pupil-teacher ratio(headcount basis) of Kiribati in 1999 to that in 2000?
Ensure brevity in your answer.  0.78. What is the ratio of the Pupil-teacher ratio(headcount basis) of Samoa in 1999 to that in 2000?
Ensure brevity in your answer.  1. What is the ratio of the Pupil-teacher ratio(headcount basis) of Central Europe in 1999 to that in 2001?
Your response must be concise. 1.02. What is the ratio of the Pupil-teacher ratio(headcount basis) in Burundi in 1999 to that in 2001?
Offer a terse response. 1.1. What is the ratio of the Pupil-teacher ratio(headcount basis) of Kiribati in 1999 to that in 2001?
Offer a terse response. 1.04. What is the ratio of the Pupil-teacher ratio(headcount basis) in Samoa in 1999 to that in 2001?
Offer a very short reply. 0.96. What is the ratio of the Pupil-teacher ratio(headcount basis) in Central Europe in 1999 to that in 2002?
Your answer should be compact. 0.99. What is the ratio of the Pupil-teacher ratio(headcount basis) in Burundi in 1999 to that in 2002?
Provide a succinct answer. 1.13. What is the ratio of the Pupil-teacher ratio(headcount basis) in Kiribati in 1999 to that in 2002?
Give a very brief answer. 1.1. What is the ratio of the Pupil-teacher ratio(headcount basis) in Samoa in 1999 to that in 2002?
Keep it short and to the point. 0.88. What is the ratio of the Pupil-teacher ratio(headcount basis) of Central Europe in 2000 to that in 2001?
Make the answer very short. 1. What is the ratio of the Pupil-teacher ratio(headcount basis) in Burundi in 2000 to that in 2001?
Offer a terse response. 1.1. What is the ratio of the Pupil-teacher ratio(headcount basis) in Kiribati in 2000 to that in 2001?
Your answer should be compact. 1.34. What is the ratio of the Pupil-teacher ratio(headcount basis) of Samoa in 2000 to that in 2001?
Make the answer very short. 0.96. What is the ratio of the Pupil-teacher ratio(headcount basis) of Central Europe in 2000 to that in 2002?
Provide a succinct answer. 0.98. What is the ratio of the Pupil-teacher ratio(headcount basis) of Burundi in 2000 to that in 2002?
Make the answer very short. 1.13. What is the ratio of the Pupil-teacher ratio(headcount basis) in Kiribati in 2000 to that in 2002?
Offer a terse response. 1.41. What is the ratio of the Pupil-teacher ratio(headcount basis) of Samoa in 2000 to that in 2002?
Your answer should be compact. 0.88. What is the ratio of the Pupil-teacher ratio(headcount basis) in Central Europe in 2001 to that in 2002?
Keep it short and to the point. 0.98. What is the ratio of the Pupil-teacher ratio(headcount basis) of Burundi in 2001 to that in 2002?
Provide a short and direct response. 1.02. What is the ratio of the Pupil-teacher ratio(headcount basis) of Kiribati in 2001 to that in 2002?
Provide a succinct answer. 1.05. What is the ratio of the Pupil-teacher ratio(headcount basis) of Samoa in 2001 to that in 2002?
Your answer should be very brief. 0.92. What is the difference between the highest and the second highest Pupil-teacher ratio(headcount basis) of Central Europe?
Your answer should be compact. 1.42. What is the difference between the highest and the second highest Pupil-teacher ratio(headcount basis) in Burundi?
Your response must be concise. 0.05. What is the difference between the highest and the second highest Pupil-teacher ratio(headcount basis) of Kiribati?
Keep it short and to the point. 1.24. What is the difference between the highest and the second highest Pupil-teacher ratio(headcount basis) in Samoa?
Provide a succinct answer. 2.19. What is the difference between the highest and the lowest Pupil-teacher ratio(headcount basis) of Central Europe?
Your answer should be very brief. 1.79. What is the difference between the highest and the lowest Pupil-teacher ratio(headcount basis) in Burundi?
Give a very brief answer. 20.86. What is the difference between the highest and the lowest Pupil-teacher ratio(headcount basis) of Kiribati?
Provide a short and direct response. 9.23. What is the difference between the highest and the lowest Pupil-teacher ratio(headcount basis) of Samoa?
Keep it short and to the point. 8.97. 